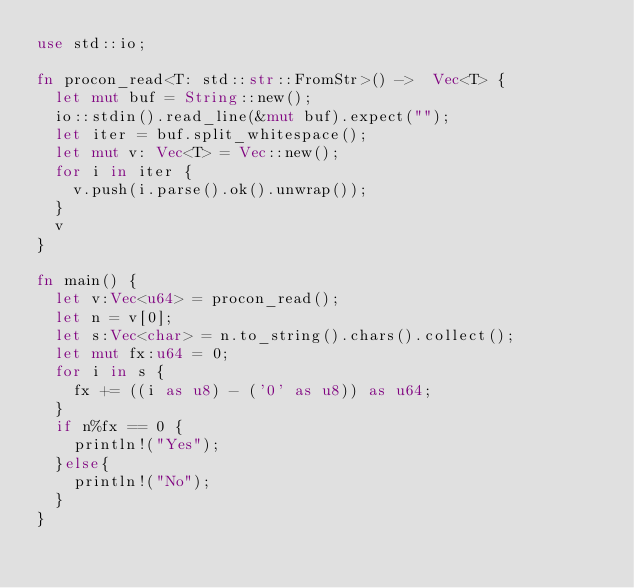<code> <loc_0><loc_0><loc_500><loc_500><_Rust_>use std::io;

fn procon_read<T: std::str::FromStr>() ->  Vec<T> {
	let mut buf = String::new();
	io::stdin().read_line(&mut buf).expect("");
	let iter = buf.split_whitespace();
	let mut v: Vec<T> = Vec::new();
	for i in iter {
		v.push(i.parse().ok().unwrap());
	}
	v
}

fn main() {
	let v:Vec<u64> = procon_read();
	let n = v[0];
	let s:Vec<char> = n.to_string().chars().collect();
	let mut fx:u64 = 0;
	for i in s {
		fx += ((i as u8) - ('0' as u8)) as u64;
	}
	if n%fx == 0 {
		println!("Yes");
	}else{
		println!("No");
	}
}</code> 